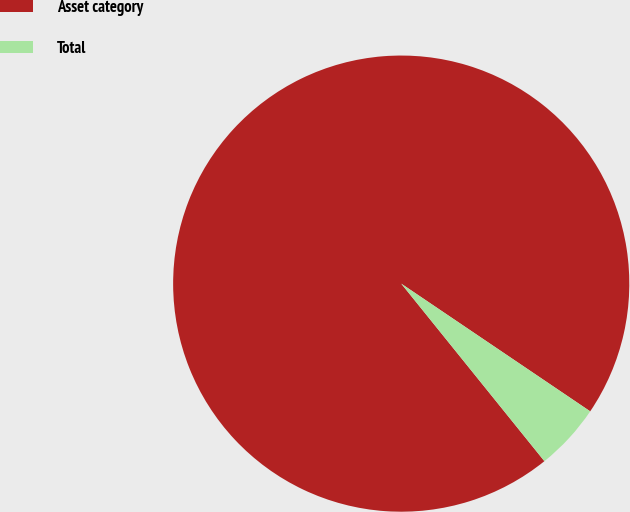Convert chart. <chart><loc_0><loc_0><loc_500><loc_500><pie_chart><fcel>Asset category<fcel>Total<nl><fcel>95.26%<fcel>4.74%<nl></chart> 